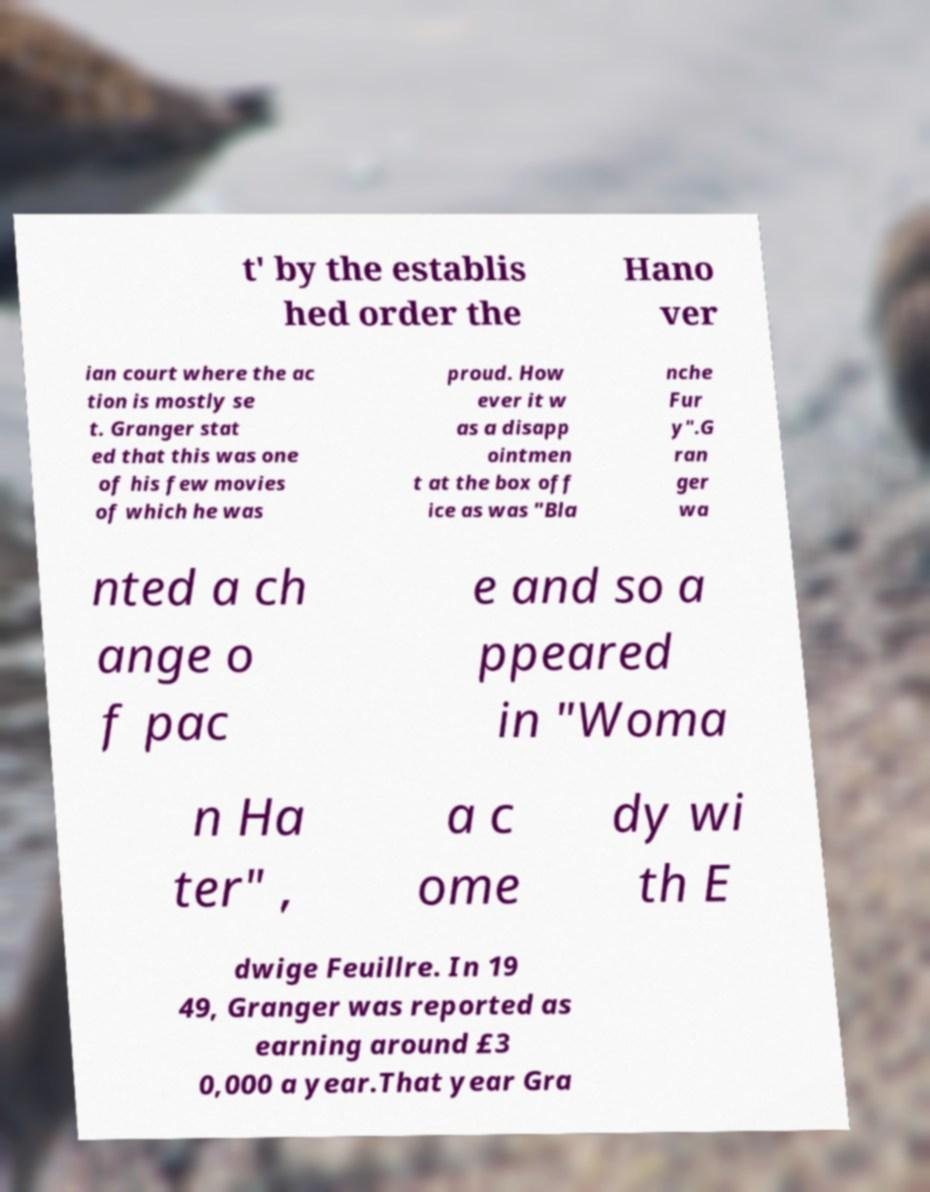Can you read and provide the text displayed in the image?This photo seems to have some interesting text. Can you extract and type it out for me? t' by the establis hed order the Hano ver ian court where the ac tion is mostly se t. Granger stat ed that this was one of his few movies of which he was proud. How ever it w as a disapp ointmen t at the box off ice as was "Bla nche Fur y".G ran ger wa nted a ch ange o f pac e and so a ppeared in "Woma n Ha ter" , a c ome dy wi th E dwige Feuillre. In 19 49, Granger was reported as earning around £3 0,000 a year.That year Gra 